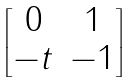<formula> <loc_0><loc_0><loc_500><loc_500>\begin{bmatrix} 0 & 1 \\ - t & - 1 \end{bmatrix}</formula> 